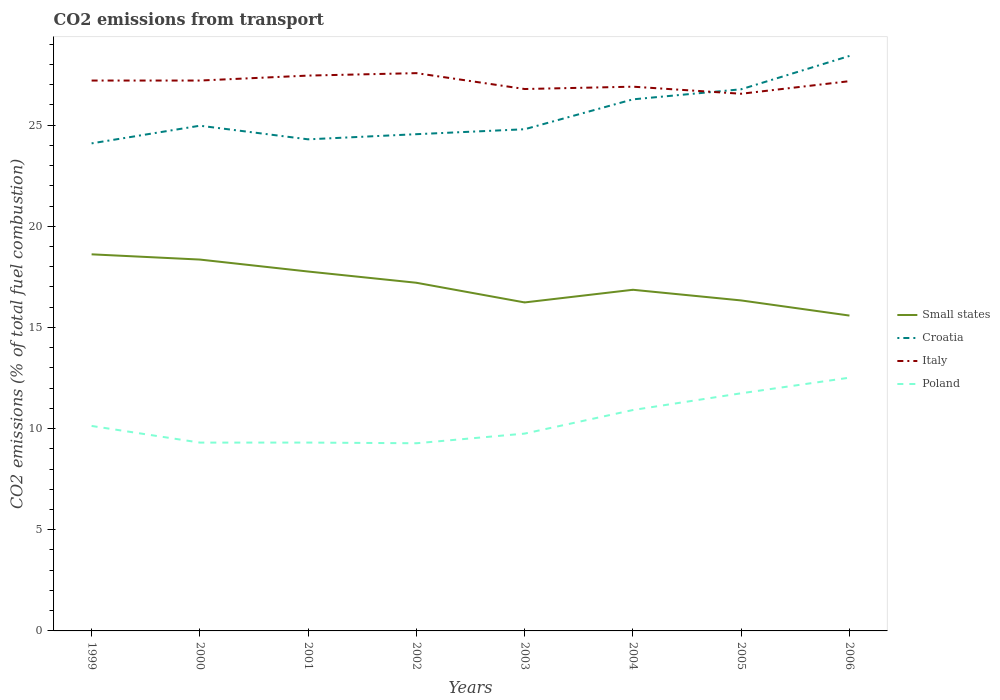How many different coloured lines are there?
Offer a very short reply. 4. Across all years, what is the maximum total CO2 emitted in Croatia?
Offer a terse response. 24.1. In which year was the total CO2 emitted in Poland maximum?
Provide a short and direct response. 2002. What is the total total CO2 emitted in Small states in the graph?
Offer a terse response. 0.97. What is the difference between the highest and the second highest total CO2 emitted in Poland?
Offer a terse response. 3.24. What is the difference between the highest and the lowest total CO2 emitted in Small states?
Provide a short and direct response. 4. Is the total CO2 emitted in Poland strictly greater than the total CO2 emitted in Croatia over the years?
Offer a very short reply. Yes. How many years are there in the graph?
Offer a very short reply. 8. Are the values on the major ticks of Y-axis written in scientific E-notation?
Offer a very short reply. No. Does the graph contain any zero values?
Provide a succinct answer. No. How are the legend labels stacked?
Offer a very short reply. Vertical. What is the title of the graph?
Your answer should be compact. CO2 emissions from transport. Does "Caribbean small states" appear as one of the legend labels in the graph?
Ensure brevity in your answer.  No. What is the label or title of the X-axis?
Offer a terse response. Years. What is the label or title of the Y-axis?
Keep it short and to the point. CO2 emissions (% of total fuel combustion). What is the CO2 emissions (% of total fuel combustion) in Small states in 1999?
Offer a very short reply. 18.61. What is the CO2 emissions (% of total fuel combustion) of Croatia in 1999?
Offer a very short reply. 24.1. What is the CO2 emissions (% of total fuel combustion) in Italy in 1999?
Provide a succinct answer. 27.2. What is the CO2 emissions (% of total fuel combustion) of Poland in 1999?
Give a very brief answer. 10.13. What is the CO2 emissions (% of total fuel combustion) of Small states in 2000?
Provide a short and direct response. 18.36. What is the CO2 emissions (% of total fuel combustion) in Croatia in 2000?
Give a very brief answer. 24.97. What is the CO2 emissions (% of total fuel combustion) in Italy in 2000?
Your response must be concise. 27.2. What is the CO2 emissions (% of total fuel combustion) in Poland in 2000?
Your response must be concise. 9.31. What is the CO2 emissions (% of total fuel combustion) in Small states in 2001?
Provide a succinct answer. 17.76. What is the CO2 emissions (% of total fuel combustion) in Croatia in 2001?
Your response must be concise. 24.3. What is the CO2 emissions (% of total fuel combustion) in Italy in 2001?
Ensure brevity in your answer.  27.45. What is the CO2 emissions (% of total fuel combustion) in Poland in 2001?
Offer a very short reply. 9.31. What is the CO2 emissions (% of total fuel combustion) of Small states in 2002?
Provide a short and direct response. 17.21. What is the CO2 emissions (% of total fuel combustion) in Croatia in 2002?
Keep it short and to the point. 24.55. What is the CO2 emissions (% of total fuel combustion) in Italy in 2002?
Your answer should be very brief. 27.57. What is the CO2 emissions (% of total fuel combustion) of Poland in 2002?
Your response must be concise. 9.28. What is the CO2 emissions (% of total fuel combustion) of Small states in 2003?
Make the answer very short. 16.24. What is the CO2 emissions (% of total fuel combustion) in Croatia in 2003?
Offer a very short reply. 24.8. What is the CO2 emissions (% of total fuel combustion) of Italy in 2003?
Provide a short and direct response. 26.79. What is the CO2 emissions (% of total fuel combustion) of Poland in 2003?
Your response must be concise. 9.75. What is the CO2 emissions (% of total fuel combustion) of Small states in 2004?
Ensure brevity in your answer.  16.86. What is the CO2 emissions (% of total fuel combustion) in Croatia in 2004?
Your answer should be very brief. 26.27. What is the CO2 emissions (% of total fuel combustion) of Italy in 2004?
Keep it short and to the point. 26.9. What is the CO2 emissions (% of total fuel combustion) of Poland in 2004?
Your answer should be very brief. 10.92. What is the CO2 emissions (% of total fuel combustion) of Small states in 2005?
Give a very brief answer. 16.34. What is the CO2 emissions (% of total fuel combustion) of Croatia in 2005?
Keep it short and to the point. 26.77. What is the CO2 emissions (% of total fuel combustion) in Italy in 2005?
Offer a terse response. 26.55. What is the CO2 emissions (% of total fuel combustion) in Poland in 2005?
Your response must be concise. 11.75. What is the CO2 emissions (% of total fuel combustion) of Small states in 2006?
Provide a succinct answer. 15.59. What is the CO2 emissions (% of total fuel combustion) of Croatia in 2006?
Give a very brief answer. 28.42. What is the CO2 emissions (% of total fuel combustion) in Italy in 2006?
Your answer should be compact. 27.17. What is the CO2 emissions (% of total fuel combustion) of Poland in 2006?
Make the answer very short. 12.52. Across all years, what is the maximum CO2 emissions (% of total fuel combustion) of Small states?
Your answer should be compact. 18.61. Across all years, what is the maximum CO2 emissions (% of total fuel combustion) of Croatia?
Offer a very short reply. 28.42. Across all years, what is the maximum CO2 emissions (% of total fuel combustion) in Italy?
Provide a short and direct response. 27.57. Across all years, what is the maximum CO2 emissions (% of total fuel combustion) of Poland?
Offer a very short reply. 12.52. Across all years, what is the minimum CO2 emissions (% of total fuel combustion) of Small states?
Your response must be concise. 15.59. Across all years, what is the minimum CO2 emissions (% of total fuel combustion) in Croatia?
Provide a short and direct response. 24.1. Across all years, what is the minimum CO2 emissions (% of total fuel combustion) in Italy?
Keep it short and to the point. 26.55. Across all years, what is the minimum CO2 emissions (% of total fuel combustion) in Poland?
Your response must be concise. 9.28. What is the total CO2 emissions (% of total fuel combustion) of Small states in the graph?
Provide a short and direct response. 136.96. What is the total CO2 emissions (% of total fuel combustion) of Croatia in the graph?
Your response must be concise. 204.18. What is the total CO2 emissions (% of total fuel combustion) of Italy in the graph?
Provide a succinct answer. 216.84. What is the total CO2 emissions (% of total fuel combustion) in Poland in the graph?
Ensure brevity in your answer.  82.96. What is the difference between the CO2 emissions (% of total fuel combustion) in Small states in 1999 and that in 2000?
Give a very brief answer. 0.26. What is the difference between the CO2 emissions (% of total fuel combustion) in Croatia in 1999 and that in 2000?
Provide a succinct answer. -0.87. What is the difference between the CO2 emissions (% of total fuel combustion) in Italy in 1999 and that in 2000?
Your answer should be compact. -0. What is the difference between the CO2 emissions (% of total fuel combustion) of Poland in 1999 and that in 2000?
Offer a terse response. 0.82. What is the difference between the CO2 emissions (% of total fuel combustion) of Small states in 1999 and that in 2001?
Your answer should be compact. 0.85. What is the difference between the CO2 emissions (% of total fuel combustion) of Croatia in 1999 and that in 2001?
Make the answer very short. -0.2. What is the difference between the CO2 emissions (% of total fuel combustion) of Italy in 1999 and that in 2001?
Keep it short and to the point. -0.25. What is the difference between the CO2 emissions (% of total fuel combustion) of Poland in 1999 and that in 2001?
Your answer should be compact. 0.82. What is the difference between the CO2 emissions (% of total fuel combustion) of Small states in 1999 and that in 2002?
Ensure brevity in your answer.  1.41. What is the difference between the CO2 emissions (% of total fuel combustion) in Croatia in 1999 and that in 2002?
Your response must be concise. -0.45. What is the difference between the CO2 emissions (% of total fuel combustion) in Italy in 1999 and that in 2002?
Your response must be concise. -0.37. What is the difference between the CO2 emissions (% of total fuel combustion) of Poland in 1999 and that in 2002?
Give a very brief answer. 0.86. What is the difference between the CO2 emissions (% of total fuel combustion) of Small states in 1999 and that in 2003?
Offer a terse response. 2.38. What is the difference between the CO2 emissions (% of total fuel combustion) in Croatia in 1999 and that in 2003?
Give a very brief answer. -0.7. What is the difference between the CO2 emissions (% of total fuel combustion) in Italy in 1999 and that in 2003?
Your answer should be very brief. 0.42. What is the difference between the CO2 emissions (% of total fuel combustion) of Poland in 1999 and that in 2003?
Keep it short and to the point. 0.38. What is the difference between the CO2 emissions (% of total fuel combustion) in Small states in 1999 and that in 2004?
Your answer should be compact. 1.75. What is the difference between the CO2 emissions (% of total fuel combustion) in Croatia in 1999 and that in 2004?
Your answer should be very brief. -2.18. What is the difference between the CO2 emissions (% of total fuel combustion) in Italy in 1999 and that in 2004?
Offer a terse response. 0.3. What is the difference between the CO2 emissions (% of total fuel combustion) in Poland in 1999 and that in 2004?
Your answer should be compact. -0.79. What is the difference between the CO2 emissions (% of total fuel combustion) in Small states in 1999 and that in 2005?
Provide a short and direct response. 2.28. What is the difference between the CO2 emissions (% of total fuel combustion) of Croatia in 1999 and that in 2005?
Make the answer very short. -2.67. What is the difference between the CO2 emissions (% of total fuel combustion) of Italy in 1999 and that in 2005?
Ensure brevity in your answer.  0.65. What is the difference between the CO2 emissions (% of total fuel combustion) in Poland in 1999 and that in 2005?
Offer a terse response. -1.62. What is the difference between the CO2 emissions (% of total fuel combustion) in Small states in 1999 and that in 2006?
Keep it short and to the point. 3.03. What is the difference between the CO2 emissions (% of total fuel combustion) in Croatia in 1999 and that in 2006?
Make the answer very short. -4.32. What is the difference between the CO2 emissions (% of total fuel combustion) of Italy in 1999 and that in 2006?
Provide a succinct answer. 0.03. What is the difference between the CO2 emissions (% of total fuel combustion) of Poland in 1999 and that in 2006?
Your answer should be very brief. -2.39. What is the difference between the CO2 emissions (% of total fuel combustion) of Small states in 2000 and that in 2001?
Make the answer very short. 0.59. What is the difference between the CO2 emissions (% of total fuel combustion) of Croatia in 2000 and that in 2001?
Your answer should be very brief. 0.67. What is the difference between the CO2 emissions (% of total fuel combustion) in Italy in 2000 and that in 2001?
Your response must be concise. -0.25. What is the difference between the CO2 emissions (% of total fuel combustion) in Poland in 2000 and that in 2001?
Keep it short and to the point. -0. What is the difference between the CO2 emissions (% of total fuel combustion) in Small states in 2000 and that in 2002?
Your answer should be very brief. 1.15. What is the difference between the CO2 emissions (% of total fuel combustion) of Croatia in 2000 and that in 2002?
Provide a short and direct response. 0.42. What is the difference between the CO2 emissions (% of total fuel combustion) in Italy in 2000 and that in 2002?
Give a very brief answer. -0.37. What is the difference between the CO2 emissions (% of total fuel combustion) in Poland in 2000 and that in 2002?
Keep it short and to the point. 0.03. What is the difference between the CO2 emissions (% of total fuel combustion) in Small states in 2000 and that in 2003?
Offer a very short reply. 2.12. What is the difference between the CO2 emissions (% of total fuel combustion) in Croatia in 2000 and that in 2003?
Ensure brevity in your answer.  0.17. What is the difference between the CO2 emissions (% of total fuel combustion) of Italy in 2000 and that in 2003?
Provide a short and direct response. 0.42. What is the difference between the CO2 emissions (% of total fuel combustion) in Poland in 2000 and that in 2003?
Keep it short and to the point. -0.44. What is the difference between the CO2 emissions (% of total fuel combustion) of Small states in 2000 and that in 2004?
Your response must be concise. 1.49. What is the difference between the CO2 emissions (% of total fuel combustion) of Croatia in 2000 and that in 2004?
Provide a short and direct response. -1.3. What is the difference between the CO2 emissions (% of total fuel combustion) in Italy in 2000 and that in 2004?
Keep it short and to the point. 0.3. What is the difference between the CO2 emissions (% of total fuel combustion) of Poland in 2000 and that in 2004?
Ensure brevity in your answer.  -1.61. What is the difference between the CO2 emissions (% of total fuel combustion) in Small states in 2000 and that in 2005?
Offer a very short reply. 2.02. What is the difference between the CO2 emissions (% of total fuel combustion) of Croatia in 2000 and that in 2005?
Your response must be concise. -1.8. What is the difference between the CO2 emissions (% of total fuel combustion) in Italy in 2000 and that in 2005?
Provide a succinct answer. 0.65. What is the difference between the CO2 emissions (% of total fuel combustion) in Poland in 2000 and that in 2005?
Offer a very short reply. -2.44. What is the difference between the CO2 emissions (% of total fuel combustion) of Small states in 2000 and that in 2006?
Provide a succinct answer. 2.77. What is the difference between the CO2 emissions (% of total fuel combustion) of Croatia in 2000 and that in 2006?
Give a very brief answer. -3.45. What is the difference between the CO2 emissions (% of total fuel combustion) of Italy in 2000 and that in 2006?
Keep it short and to the point. 0.03. What is the difference between the CO2 emissions (% of total fuel combustion) of Poland in 2000 and that in 2006?
Offer a terse response. -3.21. What is the difference between the CO2 emissions (% of total fuel combustion) of Small states in 2001 and that in 2002?
Provide a succinct answer. 0.56. What is the difference between the CO2 emissions (% of total fuel combustion) of Croatia in 2001 and that in 2002?
Offer a terse response. -0.25. What is the difference between the CO2 emissions (% of total fuel combustion) in Italy in 2001 and that in 2002?
Provide a succinct answer. -0.12. What is the difference between the CO2 emissions (% of total fuel combustion) of Poland in 2001 and that in 2002?
Keep it short and to the point. 0.03. What is the difference between the CO2 emissions (% of total fuel combustion) of Small states in 2001 and that in 2003?
Ensure brevity in your answer.  1.53. What is the difference between the CO2 emissions (% of total fuel combustion) of Croatia in 2001 and that in 2003?
Offer a terse response. -0.5. What is the difference between the CO2 emissions (% of total fuel combustion) in Italy in 2001 and that in 2003?
Provide a short and direct response. 0.66. What is the difference between the CO2 emissions (% of total fuel combustion) of Poland in 2001 and that in 2003?
Make the answer very short. -0.44. What is the difference between the CO2 emissions (% of total fuel combustion) of Small states in 2001 and that in 2004?
Ensure brevity in your answer.  0.9. What is the difference between the CO2 emissions (% of total fuel combustion) of Croatia in 2001 and that in 2004?
Offer a very short reply. -1.98. What is the difference between the CO2 emissions (% of total fuel combustion) in Italy in 2001 and that in 2004?
Your answer should be very brief. 0.55. What is the difference between the CO2 emissions (% of total fuel combustion) in Poland in 2001 and that in 2004?
Give a very brief answer. -1.61. What is the difference between the CO2 emissions (% of total fuel combustion) of Small states in 2001 and that in 2005?
Your response must be concise. 1.43. What is the difference between the CO2 emissions (% of total fuel combustion) of Croatia in 2001 and that in 2005?
Keep it short and to the point. -2.47. What is the difference between the CO2 emissions (% of total fuel combustion) of Italy in 2001 and that in 2005?
Provide a succinct answer. 0.9. What is the difference between the CO2 emissions (% of total fuel combustion) of Poland in 2001 and that in 2005?
Offer a terse response. -2.44. What is the difference between the CO2 emissions (% of total fuel combustion) in Small states in 2001 and that in 2006?
Make the answer very short. 2.18. What is the difference between the CO2 emissions (% of total fuel combustion) in Croatia in 2001 and that in 2006?
Your response must be concise. -4.12. What is the difference between the CO2 emissions (% of total fuel combustion) of Italy in 2001 and that in 2006?
Give a very brief answer. 0.28. What is the difference between the CO2 emissions (% of total fuel combustion) of Poland in 2001 and that in 2006?
Your answer should be very brief. -3.21. What is the difference between the CO2 emissions (% of total fuel combustion) in Small states in 2002 and that in 2003?
Keep it short and to the point. 0.97. What is the difference between the CO2 emissions (% of total fuel combustion) of Croatia in 2002 and that in 2003?
Ensure brevity in your answer.  -0.24. What is the difference between the CO2 emissions (% of total fuel combustion) of Italy in 2002 and that in 2003?
Your answer should be compact. 0.78. What is the difference between the CO2 emissions (% of total fuel combustion) of Poland in 2002 and that in 2003?
Keep it short and to the point. -0.48. What is the difference between the CO2 emissions (% of total fuel combustion) in Small states in 2002 and that in 2004?
Give a very brief answer. 0.35. What is the difference between the CO2 emissions (% of total fuel combustion) in Croatia in 2002 and that in 2004?
Provide a short and direct response. -1.72. What is the difference between the CO2 emissions (% of total fuel combustion) of Italy in 2002 and that in 2004?
Your answer should be very brief. 0.67. What is the difference between the CO2 emissions (% of total fuel combustion) of Poland in 2002 and that in 2004?
Keep it short and to the point. -1.64. What is the difference between the CO2 emissions (% of total fuel combustion) in Small states in 2002 and that in 2005?
Provide a short and direct response. 0.87. What is the difference between the CO2 emissions (% of total fuel combustion) in Croatia in 2002 and that in 2005?
Keep it short and to the point. -2.22. What is the difference between the CO2 emissions (% of total fuel combustion) of Poland in 2002 and that in 2005?
Offer a terse response. -2.47. What is the difference between the CO2 emissions (% of total fuel combustion) in Small states in 2002 and that in 2006?
Your response must be concise. 1.62. What is the difference between the CO2 emissions (% of total fuel combustion) in Croatia in 2002 and that in 2006?
Your response must be concise. -3.87. What is the difference between the CO2 emissions (% of total fuel combustion) of Italy in 2002 and that in 2006?
Your answer should be compact. 0.4. What is the difference between the CO2 emissions (% of total fuel combustion) in Poland in 2002 and that in 2006?
Offer a terse response. -3.24. What is the difference between the CO2 emissions (% of total fuel combustion) in Small states in 2003 and that in 2004?
Give a very brief answer. -0.63. What is the difference between the CO2 emissions (% of total fuel combustion) of Croatia in 2003 and that in 2004?
Make the answer very short. -1.48. What is the difference between the CO2 emissions (% of total fuel combustion) of Italy in 2003 and that in 2004?
Your answer should be compact. -0.12. What is the difference between the CO2 emissions (% of total fuel combustion) in Poland in 2003 and that in 2004?
Offer a terse response. -1.17. What is the difference between the CO2 emissions (% of total fuel combustion) of Small states in 2003 and that in 2005?
Your answer should be very brief. -0.1. What is the difference between the CO2 emissions (% of total fuel combustion) in Croatia in 2003 and that in 2005?
Ensure brevity in your answer.  -1.98. What is the difference between the CO2 emissions (% of total fuel combustion) of Italy in 2003 and that in 2005?
Offer a terse response. 0.23. What is the difference between the CO2 emissions (% of total fuel combustion) of Poland in 2003 and that in 2005?
Keep it short and to the point. -1.99. What is the difference between the CO2 emissions (% of total fuel combustion) in Small states in 2003 and that in 2006?
Your answer should be compact. 0.65. What is the difference between the CO2 emissions (% of total fuel combustion) of Croatia in 2003 and that in 2006?
Provide a short and direct response. -3.62. What is the difference between the CO2 emissions (% of total fuel combustion) in Italy in 2003 and that in 2006?
Offer a very short reply. -0.39. What is the difference between the CO2 emissions (% of total fuel combustion) of Poland in 2003 and that in 2006?
Offer a very short reply. -2.76. What is the difference between the CO2 emissions (% of total fuel combustion) in Small states in 2004 and that in 2005?
Offer a terse response. 0.53. What is the difference between the CO2 emissions (% of total fuel combustion) in Croatia in 2004 and that in 2005?
Your response must be concise. -0.5. What is the difference between the CO2 emissions (% of total fuel combustion) of Italy in 2004 and that in 2005?
Your response must be concise. 0.35. What is the difference between the CO2 emissions (% of total fuel combustion) of Poland in 2004 and that in 2005?
Offer a very short reply. -0.83. What is the difference between the CO2 emissions (% of total fuel combustion) in Small states in 2004 and that in 2006?
Provide a short and direct response. 1.27. What is the difference between the CO2 emissions (% of total fuel combustion) of Croatia in 2004 and that in 2006?
Your answer should be compact. -2.15. What is the difference between the CO2 emissions (% of total fuel combustion) in Italy in 2004 and that in 2006?
Provide a succinct answer. -0.27. What is the difference between the CO2 emissions (% of total fuel combustion) of Poland in 2004 and that in 2006?
Your answer should be very brief. -1.6. What is the difference between the CO2 emissions (% of total fuel combustion) in Small states in 2005 and that in 2006?
Offer a very short reply. 0.75. What is the difference between the CO2 emissions (% of total fuel combustion) in Croatia in 2005 and that in 2006?
Keep it short and to the point. -1.65. What is the difference between the CO2 emissions (% of total fuel combustion) of Italy in 2005 and that in 2006?
Provide a succinct answer. -0.62. What is the difference between the CO2 emissions (% of total fuel combustion) in Poland in 2005 and that in 2006?
Make the answer very short. -0.77. What is the difference between the CO2 emissions (% of total fuel combustion) in Small states in 1999 and the CO2 emissions (% of total fuel combustion) in Croatia in 2000?
Your answer should be very brief. -6.36. What is the difference between the CO2 emissions (% of total fuel combustion) in Small states in 1999 and the CO2 emissions (% of total fuel combustion) in Italy in 2000?
Offer a terse response. -8.59. What is the difference between the CO2 emissions (% of total fuel combustion) of Small states in 1999 and the CO2 emissions (% of total fuel combustion) of Poland in 2000?
Provide a succinct answer. 9.31. What is the difference between the CO2 emissions (% of total fuel combustion) in Croatia in 1999 and the CO2 emissions (% of total fuel combustion) in Italy in 2000?
Offer a very short reply. -3.11. What is the difference between the CO2 emissions (% of total fuel combustion) in Croatia in 1999 and the CO2 emissions (% of total fuel combustion) in Poland in 2000?
Offer a very short reply. 14.79. What is the difference between the CO2 emissions (% of total fuel combustion) in Italy in 1999 and the CO2 emissions (% of total fuel combustion) in Poland in 2000?
Your answer should be very brief. 17.9. What is the difference between the CO2 emissions (% of total fuel combustion) of Small states in 1999 and the CO2 emissions (% of total fuel combustion) of Croatia in 2001?
Offer a terse response. -5.68. What is the difference between the CO2 emissions (% of total fuel combustion) in Small states in 1999 and the CO2 emissions (% of total fuel combustion) in Italy in 2001?
Provide a succinct answer. -8.83. What is the difference between the CO2 emissions (% of total fuel combustion) of Small states in 1999 and the CO2 emissions (% of total fuel combustion) of Poland in 2001?
Ensure brevity in your answer.  9.3. What is the difference between the CO2 emissions (% of total fuel combustion) in Croatia in 1999 and the CO2 emissions (% of total fuel combustion) in Italy in 2001?
Provide a succinct answer. -3.35. What is the difference between the CO2 emissions (% of total fuel combustion) in Croatia in 1999 and the CO2 emissions (% of total fuel combustion) in Poland in 2001?
Your answer should be compact. 14.79. What is the difference between the CO2 emissions (% of total fuel combustion) in Italy in 1999 and the CO2 emissions (% of total fuel combustion) in Poland in 2001?
Provide a short and direct response. 17.89. What is the difference between the CO2 emissions (% of total fuel combustion) in Small states in 1999 and the CO2 emissions (% of total fuel combustion) in Croatia in 2002?
Your response must be concise. -5.94. What is the difference between the CO2 emissions (% of total fuel combustion) of Small states in 1999 and the CO2 emissions (% of total fuel combustion) of Italy in 2002?
Make the answer very short. -8.96. What is the difference between the CO2 emissions (% of total fuel combustion) of Small states in 1999 and the CO2 emissions (% of total fuel combustion) of Poland in 2002?
Provide a succinct answer. 9.34. What is the difference between the CO2 emissions (% of total fuel combustion) of Croatia in 1999 and the CO2 emissions (% of total fuel combustion) of Italy in 2002?
Ensure brevity in your answer.  -3.47. What is the difference between the CO2 emissions (% of total fuel combustion) of Croatia in 1999 and the CO2 emissions (% of total fuel combustion) of Poland in 2002?
Offer a terse response. 14.82. What is the difference between the CO2 emissions (% of total fuel combustion) in Italy in 1999 and the CO2 emissions (% of total fuel combustion) in Poland in 2002?
Keep it short and to the point. 17.93. What is the difference between the CO2 emissions (% of total fuel combustion) in Small states in 1999 and the CO2 emissions (% of total fuel combustion) in Croatia in 2003?
Your answer should be compact. -6.18. What is the difference between the CO2 emissions (% of total fuel combustion) in Small states in 1999 and the CO2 emissions (% of total fuel combustion) in Italy in 2003?
Offer a very short reply. -8.17. What is the difference between the CO2 emissions (% of total fuel combustion) of Small states in 1999 and the CO2 emissions (% of total fuel combustion) of Poland in 2003?
Provide a short and direct response. 8.86. What is the difference between the CO2 emissions (% of total fuel combustion) in Croatia in 1999 and the CO2 emissions (% of total fuel combustion) in Italy in 2003?
Provide a short and direct response. -2.69. What is the difference between the CO2 emissions (% of total fuel combustion) in Croatia in 1999 and the CO2 emissions (% of total fuel combustion) in Poland in 2003?
Keep it short and to the point. 14.35. What is the difference between the CO2 emissions (% of total fuel combustion) of Italy in 1999 and the CO2 emissions (% of total fuel combustion) of Poland in 2003?
Your answer should be compact. 17.45. What is the difference between the CO2 emissions (% of total fuel combustion) in Small states in 1999 and the CO2 emissions (% of total fuel combustion) in Croatia in 2004?
Your response must be concise. -7.66. What is the difference between the CO2 emissions (% of total fuel combustion) of Small states in 1999 and the CO2 emissions (% of total fuel combustion) of Italy in 2004?
Your answer should be very brief. -8.29. What is the difference between the CO2 emissions (% of total fuel combustion) in Small states in 1999 and the CO2 emissions (% of total fuel combustion) in Poland in 2004?
Offer a very short reply. 7.7. What is the difference between the CO2 emissions (% of total fuel combustion) in Croatia in 1999 and the CO2 emissions (% of total fuel combustion) in Italy in 2004?
Offer a very short reply. -2.8. What is the difference between the CO2 emissions (% of total fuel combustion) in Croatia in 1999 and the CO2 emissions (% of total fuel combustion) in Poland in 2004?
Offer a very short reply. 13.18. What is the difference between the CO2 emissions (% of total fuel combustion) of Italy in 1999 and the CO2 emissions (% of total fuel combustion) of Poland in 2004?
Keep it short and to the point. 16.29. What is the difference between the CO2 emissions (% of total fuel combustion) of Small states in 1999 and the CO2 emissions (% of total fuel combustion) of Croatia in 2005?
Your answer should be compact. -8.16. What is the difference between the CO2 emissions (% of total fuel combustion) of Small states in 1999 and the CO2 emissions (% of total fuel combustion) of Italy in 2005?
Make the answer very short. -7.94. What is the difference between the CO2 emissions (% of total fuel combustion) in Small states in 1999 and the CO2 emissions (% of total fuel combustion) in Poland in 2005?
Make the answer very short. 6.87. What is the difference between the CO2 emissions (% of total fuel combustion) in Croatia in 1999 and the CO2 emissions (% of total fuel combustion) in Italy in 2005?
Your answer should be compact. -2.45. What is the difference between the CO2 emissions (% of total fuel combustion) of Croatia in 1999 and the CO2 emissions (% of total fuel combustion) of Poland in 2005?
Your answer should be very brief. 12.35. What is the difference between the CO2 emissions (% of total fuel combustion) of Italy in 1999 and the CO2 emissions (% of total fuel combustion) of Poland in 2005?
Your answer should be very brief. 15.46. What is the difference between the CO2 emissions (% of total fuel combustion) of Small states in 1999 and the CO2 emissions (% of total fuel combustion) of Croatia in 2006?
Your response must be concise. -9.81. What is the difference between the CO2 emissions (% of total fuel combustion) in Small states in 1999 and the CO2 emissions (% of total fuel combustion) in Italy in 2006?
Keep it short and to the point. -8.56. What is the difference between the CO2 emissions (% of total fuel combustion) of Small states in 1999 and the CO2 emissions (% of total fuel combustion) of Poland in 2006?
Make the answer very short. 6.1. What is the difference between the CO2 emissions (% of total fuel combustion) in Croatia in 1999 and the CO2 emissions (% of total fuel combustion) in Italy in 2006?
Make the answer very short. -3.07. What is the difference between the CO2 emissions (% of total fuel combustion) in Croatia in 1999 and the CO2 emissions (% of total fuel combustion) in Poland in 2006?
Your answer should be very brief. 11.58. What is the difference between the CO2 emissions (% of total fuel combustion) of Italy in 1999 and the CO2 emissions (% of total fuel combustion) of Poland in 2006?
Ensure brevity in your answer.  14.69. What is the difference between the CO2 emissions (% of total fuel combustion) in Small states in 2000 and the CO2 emissions (% of total fuel combustion) in Croatia in 2001?
Provide a succinct answer. -5.94. What is the difference between the CO2 emissions (% of total fuel combustion) in Small states in 2000 and the CO2 emissions (% of total fuel combustion) in Italy in 2001?
Give a very brief answer. -9.09. What is the difference between the CO2 emissions (% of total fuel combustion) of Small states in 2000 and the CO2 emissions (% of total fuel combustion) of Poland in 2001?
Your answer should be very brief. 9.05. What is the difference between the CO2 emissions (% of total fuel combustion) in Croatia in 2000 and the CO2 emissions (% of total fuel combustion) in Italy in 2001?
Provide a succinct answer. -2.48. What is the difference between the CO2 emissions (% of total fuel combustion) in Croatia in 2000 and the CO2 emissions (% of total fuel combustion) in Poland in 2001?
Your response must be concise. 15.66. What is the difference between the CO2 emissions (% of total fuel combustion) of Italy in 2000 and the CO2 emissions (% of total fuel combustion) of Poland in 2001?
Keep it short and to the point. 17.89. What is the difference between the CO2 emissions (% of total fuel combustion) of Small states in 2000 and the CO2 emissions (% of total fuel combustion) of Croatia in 2002?
Make the answer very short. -6.2. What is the difference between the CO2 emissions (% of total fuel combustion) in Small states in 2000 and the CO2 emissions (% of total fuel combustion) in Italy in 2002?
Ensure brevity in your answer.  -9.21. What is the difference between the CO2 emissions (% of total fuel combustion) of Small states in 2000 and the CO2 emissions (% of total fuel combustion) of Poland in 2002?
Your response must be concise. 9.08. What is the difference between the CO2 emissions (% of total fuel combustion) of Croatia in 2000 and the CO2 emissions (% of total fuel combustion) of Italy in 2002?
Keep it short and to the point. -2.6. What is the difference between the CO2 emissions (% of total fuel combustion) of Croatia in 2000 and the CO2 emissions (% of total fuel combustion) of Poland in 2002?
Offer a terse response. 15.7. What is the difference between the CO2 emissions (% of total fuel combustion) in Italy in 2000 and the CO2 emissions (% of total fuel combustion) in Poland in 2002?
Your answer should be very brief. 17.93. What is the difference between the CO2 emissions (% of total fuel combustion) in Small states in 2000 and the CO2 emissions (% of total fuel combustion) in Croatia in 2003?
Ensure brevity in your answer.  -6.44. What is the difference between the CO2 emissions (% of total fuel combustion) of Small states in 2000 and the CO2 emissions (% of total fuel combustion) of Italy in 2003?
Offer a very short reply. -8.43. What is the difference between the CO2 emissions (% of total fuel combustion) of Small states in 2000 and the CO2 emissions (% of total fuel combustion) of Poland in 2003?
Ensure brevity in your answer.  8.6. What is the difference between the CO2 emissions (% of total fuel combustion) in Croatia in 2000 and the CO2 emissions (% of total fuel combustion) in Italy in 2003?
Offer a terse response. -1.81. What is the difference between the CO2 emissions (% of total fuel combustion) of Croatia in 2000 and the CO2 emissions (% of total fuel combustion) of Poland in 2003?
Ensure brevity in your answer.  15.22. What is the difference between the CO2 emissions (% of total fuel combustion) in Italy in 2000 and the CO2 emissions (% of total fuel combustion) in Poland in 2003?
Give a very brief answer. 17.45. What is the difference between the CO2 emissions (% of total fuel combustion) in Small states in 2000 and the CO2 emissions (% of total fuel combustion) in Croatia in 2004?
Give a very brief answer. -7.92. What is the difference between the CO2 emissions (% of total fuel combustion) of Small states in 2000 and the CO2 emissions (% of total fuel combustion) of Italy in 2004?
Provide a succinct answer. -8.55. What is the difference between the CO2 emissions (% of total fuel combustion) in Small states in 2000 and the CO2 emissions (% of total fuel combustion) in Poland in 2004?
Make the answer very short. 7.44. What is the difference between the CO2 emissions (% of total fuel combustion) in Croatia in 2000 and the CO2 emissions (% of total fuel combustion) in Italy in 2004?
Make the answer very short. -1.93. What is the difference between the CO2 emissions (% of total fuel combustion) in Croatia in 2000 and the CO2 emissions (% of total fuel combustion) in Poland in 2004?
Make the answer very short. 14.05. What is the difference between the CO2 emissions (% of total fuel combustion) of Italy in 2000 and the CO2 emissions (% of total fuel combustion) of Poland in 2004?
Your answer should be very brief. 16.29. What is the difference between the CO2 emissions (% of total fuel combustion) in Small states in 2000 and the CO2 emissions (% of total fuel combustion) in Croatia in 2005?
Make the answer very short. -8.42. What is the difference between the CO2 emissions (% of total fuel combustion) in Small states in 2000 and the CO2 emissions (% of total fuel combustion) in Italy in 2005?
Make the answer very short. -8.2. What is the difference between the CO2 emissions (% of total fuel combustion) of Small states in 2000 and the CO2 emissions (% of total fuel combustion) of Poland in 2005?
Your response must be concise. 6.61. What is the difference between the CO2 emissions (% of total fuel combustion) in Croatia in 2000 and the CO2 emissions (% of total fuel combustion) in Italy in 2005?
Your answer should be compact. -1.58. What is the difference between the CO2 emissions (% of total fuel combustion) in Croatia in 2000 and the CO2 emissions (% of total fuel combustion) in Poland in 2005?
Your answer should be very brief. 13.23. What is the difference between the CO2 emissions (% of total fuel combustion) in Italy in 2000 and the CO2 emissions (% of total fuel combustion) in Poland in 2005?
Provide a short and direct response. 15.46. What is the difference between the CO2 emissions (% of total fuel combustion) in Small states in 2000 and the CO2 emissions (% of total fuel combustion) in Croatia in 2006?
Offer a very short reply. -10.06. What is the difference between the CO2 emissions (% of total fuel combustion) in Small states in 2000 and the CO2 emissions (% of total fuel combustion) in Italy in 2006?
Provide a succinct answer. -8.82. What is the difference between the CO2 emissions (% of total fuel combustion) of Small states in 2000 and the CO2 emissions (% of total fuel combustion) of Poland in 2006?
Provide a succinct answer. 5.84. What is the difference between the CO2 emissions (% of total fuel combustion) of Croatia in 2000 and the CO2 emissions (% of total fuel combustion) of Italy in 2006?
Your response must be concise. -2.2. What is the difference between the CO2 emissions (% of total fuel combustion) of Croatia in 2000 and the CO2 emissions (% of total fuel combustion) of Poland in 2006?
Offer a terse response. 12.45. What is the difference between the CO2 emissions (% of total fuel combustion) in Italy in 2000 and the CO2 emissions (% of total fuel combustion) in Poland in 2006?
Your response must be concise. 14.69. What is the difference between the CO2 emissions (% of total fuel combustion) in Small states in 2001 and the CO2 emissions (% of total fuel combustion) in Croatia in 2002?
Provide a succinct answer. -6.79. What is the difference between the CO2 emissions (% of total fuel combustion) of Small states in 2001 and the CO2 emissions (% of total fuel combustion) of Italy in 2002?
Your answer should be very brief. -9.81. What is the difference between the CO2 emissions (% of total fuel combustion) of Small states in 2001 and the CO2 emissions (% of total fuel combustion) of Poland in 2002?
Your response must be concise. 8.49. What is the difference between the CO2 emissions (% of total fuel combustion) in Croatia in 2001 and the CO2 emissions (% of total fuel combustion) in Italy in 2002?
Your answer should be very brief. -3.27. What is the difference between the CO2 emissions (% of total fuel combustion) of Croatia in 2001 and the CO2 emissions (% of total fuel combustion) of Poland in 2002?
Give a very brief answer. 15.02. What is the difference between the CO2 emissions (% of total fuel combustion) of Italy in 2001 and the CO2 emissions (% of total fuel combustion) of Poland in 2002?
Provide a succinct answer. 18.17. What is the difference between the CO2 emissions (% of total fuel combustion) in Small states in 2001 and the CO2 emissions (% of total fuel combustion) in Croatia in 2003?
Ensure brevity in your answer.  -7.03. What is the difference between the CO2 emissions (% of total fuel combustion) of Small states in 2001 and the CO2 emissions (% of total fuel combustion) of Italy in 2003?
Offer a very short reply. -9.02. What is the difference between the CO2 emissions (% of total fuel combustion) of Small states in 2001 and the CO2 emissions (% of total fuel combustion) of Poland in 2003?
Offer a terse response. 8.01. What is the difference between the CO2 emissions (% of total fuel combustion) of Croatia in 2001 and the CO2 emissions (% of total fuel combustion) of Italy in 2003?
Provide a succinct answer. -2.49. What is the difference between the CO2 emissions (% of total fuel combustion) of Croatia in 2001 and the CO2 emissions (% of total fuel combustion) of Poland in 2003?
Offer a very short reply. 14.54. What is the difference between the CO2 emissions (% of total fuel combustion) in Italy in 2001 and the CO2 emissions (% of total fuel combustion) in Poland in 2003?
Offer a very short reply. 17.7. What is the difference between the CO2 emissions (% of total fuel combustion) of Small states in 2001 and the CO2 emissions (% of total fuel combustion) of Croatia in 2004?
Make the answer very short. -8.51. What is the difference between the CO2 emissions (% of total fuel combustion) of Small states in 2001 and the CO2 emissions (% of total fuel combustion) of Italy in 2004?
Keep it short and to the point. -9.14. What is the difference between the CO2 emissions (% of total fuel combustion) in Small states in 2001 and the CO2 emissions (% of total fuel combustion) in Poland in 2004?
Provide a succinct answer. 6.85. What is the difference between the CO2 emissions (% of total fuel combustion) in Croatia in 2001 and the CO2 emissions (% of total fuel combustion) in Italy in 2004?
Your answer should be very brief. -2.6. What is the difference between the CO2 emissions (% of total fuel combustion) of Croatia in 2001 and the CO2 emissions (% of total fuel combustion) of Poland in 2004?
Your response must be concise. 13.38. What is the difference between the CO2 emissions (% of total fuel combustion) of Italy in 2001 and the CO2 emissions (% of total fuel combustion) of Poland in 2004?
Offer a terse response. 16.53. What is the difference between the CO2 emissions (% of total fuel combustion) in Small states in 2001 and the CO2 emissions (% of total fuel combustion) in Croatia in 2005?
Give a very brief answer. -9.01. What is the difference between the CO2 emissions (% of total fuel combustion) of Small states in 2001 and the CO2 emissions (% of total fuel combustion) of Italy in 2005?
Offer a very short reply. -8.79. What is the difference between the CO2 emissions (% of total fuel combustion) in Small states in 2001 and the CO2 emissions (% of total fuel combustion) in Poland in 2005?
Offer a very short reply. 6.02. What is the difference between the CO2 emissions (% of total fuel combustion) of Croatia in 2001 and the CO2 emissions (% of total fuel combustion) of Italy in 2005?
Your answer should be very brief. -2.25. What is the difference between the CO2 emissions (% of total fuel combustion) in Croatia in 2001 and the CO2 emissions (% of total fuel combustion) in Poland in 2005?
Your answer should be compact. 12.55. What is the difference between the CO2 emissions (% of total fuel combustion) in Italy in 2001 and the CO2 emissions (% of total fuel combustion) in Poland in 2005?
Provide a succinct answer. 15.7. What is the difference between the CO2 emissions (% of total fuel combustion) of Small states in 2001 and the CO2 emissions (% of total fuel combustion) of Croatia in 2006?
Make the answer very short. -10.66. What is the difference between the CO2 emissions (% of total fuel combustion) in Small states in 2001 and the CO2 emissions (% of total fuel combustion) in Italy in 2006?
Make the answer very short. -9.41. What is the difference between the CO2 emissions (% of total fuel combustion) of Small states in 2001 and the CO2 emissions (% of total fuel combustion) of Poland in 2006?
Your response must be concise. 5.25. What is the difference between the CO2 emissions (% of total fuel combustion) in Croatia in 2001 and the CO2 emissions (% of total fuel combustion) in Italy in 2006?
Offer a very short reply. -2.87. What is the difference between the CO2 emissions (% of total fuel combustion) of Croatia in 2001 and the CO2 emissions (% of total fuel combustion) of Poland in 2006?
Give a very brief answer. 11.78. What is the difference between the CO2 emissions (% of total fuel combustion) in Italy in 2001 and the CO2 emissions (% of total fuel combustion) in Poland in 2006?
Your answer should be very brief. 14.93. What is the difference between the CO2 emissions (% of total fuel combustion) of Small states in 2002 and the CO2 emissions (% of total fuel combustion) of Croatia in 2003?
Ensure brevity in your answer.  -7.59. What is the difference between the CO2 emissions (% of total fuel combustion) in Small states in 2002 and the CO2 emissions (% of total fuel combustion) in Italy in 2003?
Make the answer very short. -9.58. What is the difference between the CO2 emissions (% of total fuel combustion) of Small states in 2002 and the CO2 emissions (% of total fuel combustion) of Poland in 2003?
Your response must be concise. 7.46. What is the difference between the CO2 emissions (% of total fuel combustion) of Croatia in 2002 and the CO2 emissions (% of total fuel combustion) of Italy in 2003?
Keep it short and to the point. -2.23. What is the difference between the CO2 emissions (% of total fuel combustion) of Croatia in 2002 and the CO2 emissions (% of total fuel combustion) of Poland in 2003?
Your answer should be very brief. 14.8. What is the difference between the CO2 emissions (% of total fuel combustion) in Italy in 2002 and the CO2 emissions (% of total fuel combustion) in Poland in 2003?
Provide a short and direct response. 17.82. What is the difference between the CO2 emissions (% of total fuel combustion) of Small states in 2002 and the CO2 emissions (% of total fuel combustion) of Croatia in 2004?
Provide a succinct answer. -9.07. What is the difference between the CO2 emissions (% of total fuel combustion) in Small states in 2002 and the CO2 emissions (% of total fuel combustion) in Italy in 2004?
Offer a very short reply. -9.69. What is the difference between the CO2 emissions (% of total fuel combustion) in Small states in 2002 and the CO2 emissions (% of total fuel combustion) in Poland in 2004?
Offer a very short reply. 6.29. What is the difference between the CO2 emissions (% of total fuel combustion) of Croatia in 2002 and the CO2 emissions (% of total fuel combustion) of Italy in 2004?
Offer a terse response. -2.35. What is the difference between the CO2 emissions (% of total fuel combustion) of Croatia in 2002 and the CO2 emissions (% of total fuel combustion) of Poland in 2004?
Keep it short and to the point. 13.63. What is the difference between the CO2 emissions (% of total fuel combustion) of Italy in 2002 and the CO2 emissions (% of total fuel combustion) of Poland in 2004?
Ensure brevity in your answer.  16.65. What is the difference between the CO2 emissions (% of total fuel combustion) in Small states in 2002 and the CO2 emissions (% of total fuel combustion) in Croatia in 2005?
Provide a short and direct response. -9.56. What is the difference between the CO2 emissions (% of total fuel combustion) of Small states in 2002 and the CO2 emissions (% of total fuel combustion) of Italy in 2005?
Ensure brevity in your answer.  -9.34. What is the difference between the CO2 emissions (% of total fuel combustion) of Small states in 2002 and the CO2 emissions (% of total fuel combustion) of Poland in 2005?
Provide a succinct answer. 5.46. What is the difference between the CO2 emissions (% of total fuel combustion) of Croatia in 2002 and the CO2 emissions (% of total fuel combustion) of Italy in 2005?
Your answer should be compact. -2. What is the difference between the CO2 emissions (% of total fuel combustion) in Croatia in 2002 and the CO2 emissions (% of total fuel combustion) in Poland in 2005?
Provide a succinct answer. 12.81. What is the difference between the CO2 emissions (% of total fuel combustion) of Italy in 2002 and the CO2 emissions (% of total fuel combustion) of Poland in 2005?
Ensure brevity in your answer.  15.82. What is the difference between the CO2 emissions (% of total fuel combustion) of Small states in 2002 and the CO2 emissions (% of total fuel combustion) of Croatia in 2006?
Your answer should be compact. -11.21. What is the difference between the CO2 emissions (% of total fuel combustion) of Small states in 2002 and the CO2 emissions (% of total fuel combustion) of Italy in 2006?
Provide a succinct answer. -9.96. What is the difference between the CO2 emissions (% of total fuel combustion) of Small states in 2002 and the CO2 emissions (% of total fuel combustion) of Poland in 2006?
Offer a very short reply. 4.69. What is the difference between the CO2 emissions (% of total fuel combustion) of Croatia in 2002 and the CO2 emissions (% of total fuel combustion) of Italy in 2006?
Make the answer very short. -2.62. What is the difference between the CO2 emissions (% of total fuel combustion) in Croatia in 2002 and the CO2 emissions (% of total fuel combustion) in Poland in 2006?
Offer a very short reply. 12.03. What is the difference between the CO2 emissions (% of total fuel combustion) of Italy in 2002 and the CO2 emissions (% of total fuel combustion) of Poland in 2006?
Ensure brevity in your answer.  15.05. What is the difference between the CO2 emissions (% of total fuel combustion) of Small states in 2003 and the CO2 emissions (% of total fuel combustion) of Croatia in 2004?
Offer a terse response. -10.04. What is the difference between the CO2 emissions (% of total fuel combustion) in Small states in 2003 and the CO2 emissions (% of total fuel combustion) in Italy in 2004?
Your answer should be very brief. -10.66. What is the difference between the CO2 emissions (% of total fuel combustion) in Small states in 2003 and the CO2 emissions (% of total fuel combustion) in Poland in 2004?
Provide a succinct answer. 5.32. What is the difference between the CO2 emissions (% of total fuel combustion) in Croatia in 2003 and the CO2 emissions (% of total fuel combustion) in Italy in 2004?
Your answer should be very brief. -2.1. What is the difference between the CO2 emissions (% of total fuel combustion) in Croatia in 2003 and the CO2 emissions (% of total fuel combustion) in Poland in 2004?
Give a very brief answer. 13.88. What is the difference between the CO2 emissions (% of total fuel combustion) in Italy in 2003 and the CO2 emissions (% of total fuel combustion) in Poland in 2004?
Your response must be concise. 15.87. What is the difference between the CO2 emissions (% of total fuel combustion) of Small states in 2003 and the CO2 emissions (% of total fuel combustion) of Croatia in 2005?
Give a very brief answer. -10.54. What is the difference between the CO2 emissions (% of total fuel combustion) of Small states in 2003 and the CO2 emissions (% of total fuel combustion) of Italy in 2005?
Your response must be concise. -10.31. What is the difference between the CO2 emissions (% of total fuel combustion) of Small states in 2003 and the CO2 emissions (% of total fuel combustion) of Poland in 2005?
Your answer should be very brief. 4.49. What is the difference between the CO2 emissions (% of total fuel combustion) of Croatia in 2003 and the CO2 emissions (% of total fuel combustion) of Italy in 2005?
Offer a very short reply. -1.75. What is the difference between the CO2 emissions (% of total fuel combustion) in Croatia in 2003 and the CO2 emissions (% of total fuel combustion) in Poland in 2005?
Give a very brief answer. 13.05. What is the difference between the CO2 emissions (% of total fuel combustion) in Italy in 2003 and the CO2 emissions (% of total fuel combustion) in Poland in 2005?
Offer a terse response. 15.04. What is the difference between the CO2 emissions (% of total fuel combustion) of Small states in 2003 and the CO2 emissions (% of total fuel combustion) of Croatia in 2006?
Ensure brevity in your answer.  -12.18. What is the difference between the CO2 emissions (% of total fuel combustion) in Small states in 2003 and the CO2 emissions (% of total fuel combustion) in Italy in 2006?
Make the answer very short. -10.94. What is the difference between the CO2 emissions (% of total fuel combustion) of Small states in 2003 and the CO2 emissions (% of total fuel combustion) of Poland in 2006?
Keep it short and to the point. 3.72. What is the difference between the CO2 emissions (% of total fuel combustion) of Croatia in 2003 and the CO2 emissions (% of total fuel combustion) of Italy in 2006?
Ensure brevity in your answer.  -2.38. What is the difference between the CO2 emissions (% of total fuel combustion) of Croatia in 2003 and the CO2 emissions (% of total fuel combustion) of Poland in 2006?
Offer a very short reply. 12.28. What is the difference between the CO2 emissions (% of total fuel combustion) in Italy in 2003 and the CO2 emissions (% of total fuel combustion) in Poland in 2006?
Make the answer very short. 14.27. What is the difference between the CO2 emissions (% of total fuel combustion) in Small states in 2004 and the CO2 emissions (% of total fuel combustion) in Croatia in 2005?
Your answer should be compact. -9.91. What is the difference between the CO2 emissions (% of total fuel combustion) in Small states in 2004 and the CO2 emissions (% of total fuel combustion) in Italy in 2005?
Offer a terse response. -9.69. What is the difference between the CO2 emissions (% of total fuel combustion) of Small states in 2004 and the CO2 emissions (% of total fuel combustion) of Poland in 2005?
Your response must be concise. 5.12. What is the difference between the CO2 emissions (% of total fuel combustion) in Croatia in 2004 and the CO2 emissions (% of total fuel combustion) in Italy in 2005?
Offer a very short reply. -0.28. What is the difference between the CO2 emissions (% of total fuel combustion) in Croatia in 2004 and the CO2 emissions (% of total fuel combustion) in Poland in 2005?
Offer a terse response. 14.53. What is the difference between the CO2 emissions (% of total fuel combustion) of Italy in 2004 and the CO2 emissions (% of total fuel combustion) of Poland in 2005?
Offer a very short reply. 15.15. What is the difference between the CO2 emissions (% of total fuel combustion) of Small states in 2004 and the CO2 emissions (% of total fuel combustion) of Croatia in 2006?
Your response must be concise. -11.56. What is the difference between the CO2 emissions (% of total fuel combustion) of Small states in 2004 and the CO2 emissions (% of total fuel combustion) of Italy in 2006?
Provide a succinct answer. -10.31. What is the difference between the CO2 emissions (% of total fuel combustion) in Small states in 2004 and the CO2 emissions (% of total fuel combustion) in Poland in 2006?
Your answer should be compact. 4.34. What is the difference between the CO2 emissions (% of total fuel combustion) of Croatia in 2004 and the CO2 emissions (% of total fuel combustion) of Italy in 2006?
Make the answer very short. -0.9. What is the difference between the CO2 emissions (% of total fuel combustion) in Croatia in 2004 and the CO2 emissions (% of total fuel combustion) in Poland in 2006?
Offer a very short reply. 13.76. What is the difference between the CO2 emissions (% of total fuel combustion) of Italy in 2004 and the CO2 emissions (% of total fuel combustion) of Poland in 2006?
Provide a short and direct response. 14.38. What is the difference between the CO2 emissions (% of total fuel combustion) in Small states in 2005 and the CO2 emissions (% of total fuel combustion) in Croatia in 2006?
Your answer should be very brief. -12.08. What is the difference between the CO2 emissions (% of total fuel combustion) of Small states in 2005 and the CO2 emissions (% of total fuel combustion) of Italy in 2006?
Ensure brevity in your answer.  -10.84. What is the difference between the CO2 emissions (% of total fuel combustion) of Small states in 2005 and the CO2 emissions (% of total fuel combustion) of Poland in 2006?
Your answer should be compact. 3.82. What is the difference between the CO2 emissions (% of total fuel combustion) of Croatia in 2005 and the CO2 emissions (% of total fuel combustion) of Italy in 2006?
Keep it short and to the point. -0.4. What is the difference between the CO2 emissions (% of total fuel combustion) in Croatia in 2005 and the CO2 emissions (% of total fuel combustion) in Poland in 2006?
Ensure brevity in your answer.  14.26. What is the difference between the CO2 emissions (% of total fuel combustion) in Italy in 2005 and the CO2 emissions (% of total fuel combustion) in Poland in 2006?
Your answer should be compact. 14.03. What is the average CO2 emissions (% of total fuel combustion) in Small states per year?
Give a very brief answer. 17.12. What is the average CO2 emissions (% of total fuel combustion) of Croatia per year?
Provide a succinct answer. 25.52. What is the average CO2 emissions (% of total fuel combustion) of Italy per year?
Give a very brief answer. 27.1. What is the average CO2 emissions (% of total fuel combustion) of Poland per year?
Provide a short and direct response. 10.37. In the year 1999, what is the difference between the CO2 emissions (% of total fuel combustion) in Small states and CO2 emissions (% of total fuel combustion) in Croatia?
Your answer should be very brief. -5.48. In the year 1999, what is the difference between the CO2 emissions (% of total fuel combustion) of Small states and CO2 emissions (% of total fuel combustion) of Italy?
Your answer should be very brief. -8.59. In the year 1999, what is the difference between the CO2 emissions (% of total fuel combustion) of Small states and CO2 emissions (% of total fuel combustion) of Poland?
Provide a short and direct response. 8.48. In the year 1999, what is the difference between the CO2 emissions (% of total fuel combustion) in Croatia and CO2 emissions (% of total fuel combustion) in Italy?
Offer a terse response. -3.11. In the year 1999, what is the difference between the CO2 emissions (% of total fuel combustion) of Croatia and CO2 emissions (% of total fuel combustion) of Poland?
Keep it short and to the point. 13.97. In the year 1999, what is the difference between the CO2 emissions (% of total fuel combustion) in Italy and CO2 emissions (% of total fuel combustion) in Poland?
Offer a very short reply. 17.07. In the year 2000, what is the difference between the CO2 emissions (% of total fuel combustion) in Small states and CO2 emissions (% of total fuel combustion) in Croatia?
Give a very brief answer. -6.62. In the year 2000, what is the difference between the CO2 emissions (% of total fuel combustion) of Small states and CO2 emissions (% of total fuel combustion) of Italy?
Your answer should be very brief. -8.85. In the year 2000, what is the difference between the CO2 emissions (% of total fuel combustion) in Small states and CO2 emissions (% of total fuel combustion) in Poland?
Give a very brief answer. 9.05. In the year 2000, what is the difference between the CO2 emissions (% of total fuel combustion) in Croatia and CO2 emissions (% of total fuel combustion) in Italy?
Keep it short and to the point. -2.23. In the year 2000, what is the difference between the CO2 emissions (% of total fuel combustion) of Croatia and CO2 emissions (% of total fuel combustion) of Poland?
Offer a terse response. 15.66. In the year 2000, what is the difference between the CO2 emissions (% of total fuel combustion) in Italy and CO2 emissions (% of total fuel combustion) in Poland?
Give a very brief answer. 17.9. In the year 2001, what is the difference between the CO2 emissions (% of total fuel combustion) of Small states and CO2 emissions (% of total fuel combustion) of Croatia?
Keep it short and to the point. -6.53. In the year 2001, what is the difference between the CO2 emissions (% of total fuel combustion) of Small states and CO2 emissions (% of total fuel combustion) of Italy?
Make the answer very short. -9.69. In the year 2001, what is the difference between the CO2 emissions (% of total fuel combustion) in Small states and CO2 emissions (% of total fuel combustion) in Poland?
Provide a succinct answer. 8.45. In the year 2001, what is the difference between the CO2 emissions (% of total fuel combustion) of Croatia and CO2 emissions (% of total fuel combustion) of Italy?
Offer a very short reply. -3.15. In the year 2001, what is the difference between the CO2 emissions (% of total fuel combustion) in Croatia and CO2 emissions (% of total fuel combustion) in Poland?
Offer a very short reply. 14.99. In the year 2001, what is the difference between the CO2 emissions (% of total fuel combustion) of Italy and CO2 emissions (% of total fuel combustion) of Poland?
Offer a very short reply. 18.14. In the year 2002, what is the difference between the CO2 emissions (% of total fuel combustion) of Small states and CO2 emissions (% of total fuel combustion) of Croatia?
Ensure brevity in your answer.  -7.34. In the year 2002, what is the difference between the CO2 emissions (% of total fuel combustion) of Small states and CO2 emissions (% of total fuel combustion) of Italy?
Make the answer very short. -10.36. In the year 2002, what is the difference between the CO2 emissions (% of total fuel combustion) in Small states and CO2 emissions (% of total fuel combustion) in Poland?
Your answer should be compact. 7.93. In the year 2002, what is the difference between the CO2 emissions (% of total fuel combustion) in Croatia and CO2 emissions (% of total fuel combustion) in Italy?
Provide a succinct answer. -3.02. In the year 2002, what is the difference between the CO2 emissions (% of total fuel combustion) in Croatia and CO2 emissions (% of total fuel combustion) in Poland?
Your answer should be compact. 15.28. In the year 2002, what is the difference between the CO2 emissions (% of total fuel combustion) of Italy and CO2 emissions (% of total fuel combustion) of Poland?
Provide a short and direct response. 18.29. In the year 2003, what is the difference between the CO2 emissions (% of total fuel combustion) of Small states and CO2 emissions (% of total fuel combustion) of Croatia?
Give a very brief answer. -8.56. In the year 2003, what is the difference between the CO2 emissions (% of total fuel combustion) of Small states and CO2 emissions (% of total fuel combustion) of Italy?
Your response must be concise. -10.55. In the year 2003, what is the difference between the CO2 emissions (% of total fuel combustion) in Small states and CO2 emissions (% of total fuel combustion) in Poland?
Offer a terse response. 6.48. In the year 2003, what is the difference between the CO2 emissions (% of total fuel combustion) of Croatia and CO2 emissions (% of total fuel combustion) of Italy?
Your response must be concise. -1.99. In the year 2003, what is the difference between the CO2 emissions (% of total fuel combustion) of Croatia and CO2 emissions (% of total fuel combustion) of Poland?
Your answer should be very brief. 15.04. In the year 2003, what is the difference between the CO2 emissions (% of total fuel combustion) in Italy and CO2 emissions (% of total fuel combustion) in Poland?
Your response must be concise. 17.03. In the year 2004, what is the difference between the CO2 emissions (% of total fuel combustion) in Small states and CO2 emissions (% of total fuel combustion) in Croatia?
Keep it short and to the point. -9.41. In the year 2004, what is the difference between the CO2 emissions (% of total fuel combustion) in Small states and CO2 emissions (% of total fuel combustion) in Italy?
Offer a very short reply. -10.04. In the year 2004, what is the difference between the CO2 emissions (% of total fuel combustion) of Small states and CO2 emissions (% of total fuel combustion) of Poland?
Make the answer very short. 5.94. In the year 2004, what is the difference between the CO2 emissions (% of total fuel combustion) of Croatia and CO2 emissions (% of total fuel combustion) of Italy?
Keep it short and to the point. -0.63. In the year 2004, what is the difference between the CO2 emissions (% of total fuel combustion) of Croatia and CO2 emissions (% of total fuel combustion) of Poland?
Give a very brief answer. 15.36. In the year 2004, what is the difference between the CO2 emissions (% of total fuel combustion) in Italy and CO2 emissions (% of total fuel combustion) in Poland?
Offer a terse response. 15.98. In the year 2005, what is the difference between the CO2 emissions (% of total fuel combustion) in Small states and CO2 emissions (% of total fuel combustion) in Croatia?
Provide a short and direct response. -10.44. In the year 2005, what is the difference between the CO2 emissions (% of total fuel combustion) of Small states and CO2 emissions (% of total fuel combustion) of Italy?
Keep it short and to the point. -10.22. In the year 2005, what is the difference between the CO2 emissions (% of total fuel combustion) of Small states and CO2 emissions (% of total fuel combustion) of Poland?
Ensure brevity in your answer.  4.59. In the year 2005, what is the difference between the CO2 emissions (% of total fuel combustion) of Croatia and CO2 emissions (% of total fuel combustion) of Italy?
Your answer should be very brief. 0.22. In the year 2005, what is the difference between the CO2 emissions (% of total fuel combustion) of Croatia and CO2 emissions (% of total fuel combustion) of Poland?
Provide a short and direct response. 15.03. In the year 2005, what is the difference between the CO2 emissions (% of total fuel combustion) of Italy and CO2 emissions (% of total fuel combustion) of Poland?
Your answer should be very brief. 14.8. In the year 2006, what is the difference between the CO2 emissions (% of total fuel combustion) of Small states and CO2 emissions (% of total fuel combustion) of Croatia?
Your answer should be very brief. -12.83. In the year 2006, what is the difference between the CO2 emissions (% of total fuel combustion) of Small states and CO2 emissions (% of total fuel combustion) of Italy?
Offer a terse response. -11.59. In the year 2006, what is the difference between the CO2 emissions (% of total fuel combustion) in Small states and CO2 emissions (% of total fuel combustion) in Poland?
Make the answer very short. 3.07. In the year 2006, what is the difference between the CO2 emissions (% of total fuel combustion) of Croatia and CO2 emissions (% of total fuel combustion) of Italy?
Keep it short and to the point. 1.25. In the year 2006, what is the difference between the CO2 emissions (% of total fuel combustion) of Croatia and CO2 emissions (% of total fuel combustion) of Poland?
Keep it short and to the point. 15.9. In the year 2006, what is the difference between the CO2 emissions (% of total fuel combustion) in Italy and CO2 emissions (% of total fuel combustion) in Poland?
Provide a succinct answer. 14.66. What is the ratio of the CO2 emissions (% of total fuel combustion) of Small states in 1999 to that in 2000?
Your answer should be very brief. 1.01. What is the ratio of the CO2 emissions (% of total fuel combustion) of Croatia in 1999 to that in 2000?
Keep it short and to the point. 0.96. What is the ratio of the CO2 emissions (% of total fuel combustion) in Poland in 1999 to that in 2000?
Provide a short and direct response. 1.09. What is the ratio of the CO2 emissions (% of total fuel combustion) of Small states in 1999 to that in 2001?
Make the answer very short. 1.05. What is the ratio of the CO2 emissions (% of total fuel combustion) of Italy in 1999 to that in 2001?
Ensure brevity in your answer.  0.99. What is the ratio of the CO2 emissions (% of total fuel combustion) in Poland in 1999 to that in 2001?
Your response must be concise. 1.09. What is the ratio of the CO2 emissions (% of total fuel combustion) of Small states in 1999 to that in 2002?
Make the answer very short. 1.08. What is the ratio of the CO2 emissions (% of total fuel combustion) of Croatia in 1999 to that in 2002?
Offer a terse response. 0.98. What is the ratio of the CO2 emissions (% of total fuel combustion) in Italy in 1999 to that in 2002?
Keep it short and to the point. 0.99. What is the ratio of the CO2 emissions (% of total fuel combustion) of Poland in 1999 to that in 2002?
Keep it short and to the point. 1.09. What is the ratio of the CO2 emissions (% of total fuel combustion) of Small states in 1999 to that in 2003?
Your answer should be very brief. 1.15. What is the ratio of the CO2 emissions (% of total fuel combustion) of Croatia in 1999 to that in 2003?
Make the answer very short. 0.97. What is the ratio of the CO2 emissions (% of total fuel combustion) in Italy in 1999 to that in 2003?
Provide a short and direct response. 1.02. What is the ratio of the CO2 emissions (% of total fuel combustion) of Poland in 1999 to that in 2003?
Your answer should be very brief. 1.04. What is the ratio of the CO2 emissions (% of total fuel combustion) of Small states in 1999 to that in 2004?
Keep it short and to the point. 1.1. What is the ratio of the CO2 emissions (% of total fuel combustion) in Croatia in 1999 to that in 2004?
Offer a terse response. 0.92. What is the ratio of the CO2 emissions (% of total fuel combustion) in Italy in 1999 to that in 2004?
Offer a very short reply. 1.01. What is the ratio of the CO2 emissions (% of total fuel combustion) of Poland in 1999 to that in 2004?
Ensure brevity in your answer.  0.93. What is the ratio of the CO2 emissions (% of total fuel combustion) in Small states in 1999 to that in 2005?
Provide a short and direct response. 1.14. What is the ratio of the CO2 emissions (% of total fuel combustion) of Croatia in 1999 to that in 2005?
Your answer should be compact. 0.9. What is the ratio of the CO2 emissions (% of total fuel combustion) of Italy in 1999 to that in 2005?
Ensure brevity in your answer.  1.02. What is the ratio of the CO2 emissions (% of total fuel combustion) in Poland in 1999 to that in 2005?
Provide a short and direct response. 0.86. What is the ratio of the CO2 emissions (% of total fuel combustion) of Small states in 1999 to that in 2006?
Keep it short and to the point. 1.19. What is the ratio of the CO2 emissions (% of total fuel combustion) of Croatia in 1999 to that in 2006?
Ensure brevity in your answer.  0.85. What is the ratio of the CO2 emissions (% of total fuel combustion) in Italy in 1999 to that in 2006?
Your answer should be compact. 1. What is the ratio of the CO2 emissions (% of total fuel combustion) in Poland in 1999 to that in 2006?
Offer a terse response. 0.81. What is the ratio of the CO2 emissions (% of total fuel combustion) in Croatia in 2000 to that in 2001?
Your answer should be very brief. 1.03. What is the ratio of the CO2 emissions (% of total fuel combustion) in Italy in 2000 to that in 2001?
Make the answer very short. 0.99. What is the ratio of the CO2 emissions (% of total fuel combustion) in Small states in 2000 to that in 2002?
Give a very brief answer. 1.07. What is the ratio of the CO2 emissions (% of total fuel combustion) in Croatia in 2000 to that in 2002?
Make the answer very short. 1.02. What is the ratio of the CO2 emissions (% of total fuel combustion) in Italy in 2000 to that in 2002?
Offer a terse response. 0.99. What is the ratio of the CO2 emissions (% of total fuel combustion) in Poland in 2000 to that in 2002?
Your answer should be compact. 1. What is the ratio of the CO2 emissions (% of total fuel combustion) of Small states in 2000 to that in 2003?
Offer a very short reply. 1.13. What is the ratio of the CO2 emissions (% of total fuel combustion) in Italy in 2000 to that in 2003?
Offer a very short reply. 1.02. What is the ratio of the CO2 emissions (% of total fuel combustion) in Poland in 2000 to that in 2003?
Your answer should be very brief. 0.95. What is the ratio of the CO2 emissions (% of total fuel combustion) of Small states in 2000 to that in 2004?
Keep it short and to the point. 1.09. What is the ratio of the CO2 emissions (% of total fuel combustion) in Croatia in 2000 to that in 2004?
Provide a succinct answer. 0.95. What is the ratio of the CO2 emissions (% of total fuel combustion) in Italy in 2000 to that in 2004?
Keep it short and to the point. 1.01. What is the ratio of the CO2 emissions (% of total fuel combustion) in Poland in 2000 to that in 2004?
Make the answer very short. 0.85. What is the ratio of the CO2 emissions (% of total fuel combustion) of Small states in 2000 to that in 2005?
Provide a short and direct response. 1.12. What is the ratio of the CO2 emissions (% of total fuel combustion) in Croatia in 2000 to that in 2005?
Give a very brief answer. 0.93. What is the ratio of the CO2 emissions (% of total fuel combustion) in Italy in 2000 to that in 2005?
Your answer should be compact. 1.02. What is the ratio of the CO2 emissions (% of total fuel combustion) of Poland in 2000 to that in 2005?
Your answer should be compact. 0.79. What is the ratio of the CO2 emissions (% of total fuel combustion) of Small states in 2000 to that in 2006?
Your answer should be compact. 1.18. What is the ratio of the CO2 emissions (% of total fuel combustion) of Croatia in 2000 to that in 2006?
Provide a short and direct response. 0.88. What is the ratio of the CO2 emissions (% of total fuel combustion) of Italy in 2000 to that in 2006?
Make the answer very short. 1. What is the ratio of the CO2 emissions (% of total fuel combustion) in Poland in 2000 to that in 2006?
Provide a short and direct response. 0.74. What is the ratio of the CO2 emissions (% of total fuel combustion) in Small states in 2001 to that in 2002?
Keep it short and to the point. 1.03. What is the ratio of the CO2 emissions (% of total fuel combustion) of Small states in 2001 to that in 2003?
Provide a short and direct response. 1.09. What is the ratio of the CO2 emissions (% of total fuel combustion) in Croatia in 2001 to that in 2003?
Give a very brief answer. 0.98. What is the ratio of the CO2 emissions (% of total fuel combustion) of Italy in 2001 to that in 2003?
Offer a terse response. 1.02. What is the ratio of the CO2 emissions (% of total fuel combustion) of Poland in 2001 to that in 2003?
Your answer should be very brief. 0.95. What is the ratio of the CO2 emissions (% of total fuel combustion) of Small states in 2001 to that in 2004?
Your response must be concise. 1.05. What is the ratio of the CO2 emissions (% of total fuel combustion) of Croatia in 2001 to that in 2004?
Your answer should be compact. 0.92. What is the ratio of the CO2 emissions (% of total fuel combustion) of Italy in 2001 to that in 2004?
Provide a succinct answer. 1.02. What is the ratio of the CO2 emissions (% of total fuel combustion) of Poland in 2001 to that in 2004?
Offer a terse response. 0.85. What is the ratio of the CO2 emissions (% of total fuel combustion) in Small states in 2001 to that in 2005?
Offer a terse response. 1.09. What is the ratio of the CO2 emissions (% of total fuel combustion) of Croatia in 2001 to that in 2005?
Your answer should be very brief. 0.91. What is the ratio of the CO2 emissions (% of total fuel combustion) of Italy in 2001 to that in 2005?
Provide a short and direct response. 1.03. What is the ratio of the CO2 emissions (% of total fuel combustion) of Poland in 2001 to that in 2005?
Give a very brief answer. 0.79. What is the ratio of the CO2 emissions (% of total fuel combustion) of Small states in 2001 to that in 2006?
Give a very brief answer. 1.14. What is the ratio of the CO2 emissions (% of total fuel combustion) in Croatia in 2001 to that in 2006?
Your response must be concise. 0.85. What is the ratio of the CO2 emissions (% of total fuel combustion) of Italy in 2001 to that in 2006?
Keep it short and to the point. 1.01. What is the ratio of the CO2 emissions (% of total fuel combustion) in Poland in 2001 to that in 2006?
Make the answer very short. 0.74. What is the ratio of the CO2 emissions (% of total fuel combustion) of Small states in 2002 to that in 2003?
Give a very brief answer. 1.06. What is the ratio of the CO2 emissions (% of total fuel combustion) of Italy in 2002 to that in 2003?
Make the answer very short. 1.03. What is the ratio of the CO2 emissions (% of total fuel combustion) in Poland in 2002 to that in 2003?
Ensure brevity in your answer.  0.95. What is the ratio of the CO2 emissions (% of total fuel combustion) of Small states in 2002 to that in 2004?
Make the answer very short. 1.02. What is the ratio of the CO2 emissions (% of total fuel combustion) of Croatia in 2002 to that in 2004?
Make the answer very short. 0.93. What is the ratio of the CO2 emissions (% of total fuel combustion) in Italy in 2002 to that in 2004?
Provide a succinct answer. 1.02. What is the ratio of the CO2 emissions (% of total fuel combustion) of Poland in 2002 to that in 2004?
Keep it short and to the point. 0.85. What is the ratio of the CO2 emissions (% of total fuel combustion) of Small states in 2002 to that in 2005?
Provide a short and direct response. 1.05. What is the ratio of the CO2 emissions (% of total fuel combustion) in Croatia in 2002 to that in 2005?
Give a very brief answer. 0.92. What is the ratio of the CO2 emissions (% of total fuel combustion) of Italy in 2002 to that in 2005?
Offer a very short reply. 1.04. What is the ratio of the CO2 emissions (% of total fuel combustion) of Poland in 2002 to that in 2005?
Offer a very short reply. 0.79. What is the ratio of the CO2 emissions (% of total fuel combustion) in Small states in 2002 to that in 2006?
Offer a very short reply. 1.1. What is the ratio of the CO2 emissions (% of total fuel combustion) in Croatia in 2002 to that in 2006?
Keep it short and to the point. 0.86. What is the ratio of the CO2 emissions (% of total fuel combustion) in Italy in 2002 to that in 2006?
Keep it short and to the point. 1.01. What is the ratio of the CO2 emissions (% of total fuel combustion) of Poland in 2002 to that in 2006?
Your answer should be compact. 0.74. What is the ratio of the CO2 emissions (% of total fuel combustion) of Small states in 2003 to that in 2004?
Offer a very short reply. 0.96. What is the ratio of the CO2 emissions (% of total fuel combustion) of Croatia in 2003 to that in 2004?
Provide a short and direct response. 0.94. What is the ratio of the CO2 emissions (% of total fuel combustion) of Italy in 2003 to that in 2004?
Your answer should be very brief. 1. What is the ratio of the CO2 emissions (% of total fuel combustion) of Poland in 2003 to that in 2004?
Keep it short and to the point. 0.89. What is the ratio of the CO2 emissions (% of total fuel combustion) of Croatia in 2003 to that in 2005?
Provide a short and direct response. 0.93. What is the ratio of the CO2 emissions (% of total fuel combustion) in Italy in 2003 to that in 2005?
Ensure brevity in your answer.  1.01. What is the ratio of the CO2 emissions (% of total fuel combustion) of Poland in 2003 to that in 2005?
Provide a short and direct response. 0.83. What is the ratio of the CO2 emissions (% of total fuel combustion) in Small states in 2003 to that in 2006?
Provide a short and direct response. 1.04. What is the ratio of the CO2 emissions (% of total fuel combustion) in Croatia in 2003 to that in 2006?
Offer a very short reply. 0.87. What is the ratio of the CO2 emissions (% of total fuel combustion) of Italy in 2003 to that in 2006?
Provide a succinct answer. 0.99. What is the ratio of the CO2 emissions (% of total fuel combustion) in Poland in 2003 to that in 2006?
Keep it short and to the point. 0.78. What is the ratio of the CO2 emissions (% of total fuel combustion) in Small states in 2004 to that in 2005?
Offer a very short reply. 1.03. What is the ratio of the CO2 emissions (% of total fuel combustion) in Croatia in 2004 to that in 2005?
Provide a succinct answer. 0.98. What is the ratio of the CO2 emissions (% of total fuel combustion) of Italy in 2004 to that in 2005?
Offer a terse response. 1.01. What is the ratio of the CO2 emissions (% of total fuel combustion) in Poland in 2004 to that in 2005?
Provide a short and direct response. 0.93. What is the ratio of the CO2 emissions (% of total fuel combustion) of Small states in 2004 to that in 2006?
Ensure brevity in your answer.  1.08. What is the ratio of the CO2 emissions (% of total fuel combustion) of Croatia in 2004 to that in 2006?
Provide a succinct answer. 0.92. What is the ratio of the CO2 emissions (% of total fuel combustion) in Poland in 2004 to that in 2006?
Offer a terse response. 0.87. What is the ratio of the CO2 emissions (% of total fuel combustion) of Small states in 2005 to that in 2006?
Make the answer very short. 1.05. What is the ratio of the CO2 emissions (% of total fuel combustion) in Croatia in 2005 to that in 2006?
Offer a very short reply. 0.94. What is the ratio of the CO2 emissions (% of total fuel combustion) of Italy in 2005 to that in 2006?
Provide a short and direct response. 0.98. What is the ratio of the CO2 emissions (% of total fuel combustion) of Poland in 2005 to that in 2006?
Provide a short and direct response. 0.94. What is the difference between the highest and the second highest CO2 emissions (% of total fuel combustion) of Small states?
Offer a terse response. 0.26. What is the difference between the highest and the second highest CO2 emissions (% of total fuel combustion) in Croatia?
Keep it short and to the point. 1.65. What is the difference between the highest and the second highest CO2 emissions (% of total fuel combustion) of Italy?
Your answer should be very brief. 0.12. What is the difference between the highest and the second highest CO2 emissions (% of total fuel combustion) of Poland?
Your answer should be very brief. 0.77. What is the difference between the highest and the lowest CO2 emissions (% of total fuel combustion) in Small states?
Offer a very short reply. 3.03. What is the difference between the highest and the lowest CO2 emissions (% of total fuel combustion) of Croatia?
Provide a succinct answer. 4.32. What is the difference between the highest and the lowest CO2 emissions (% of total fuel combustion) in Poland?
Keep it short and to the point. 3.24. 